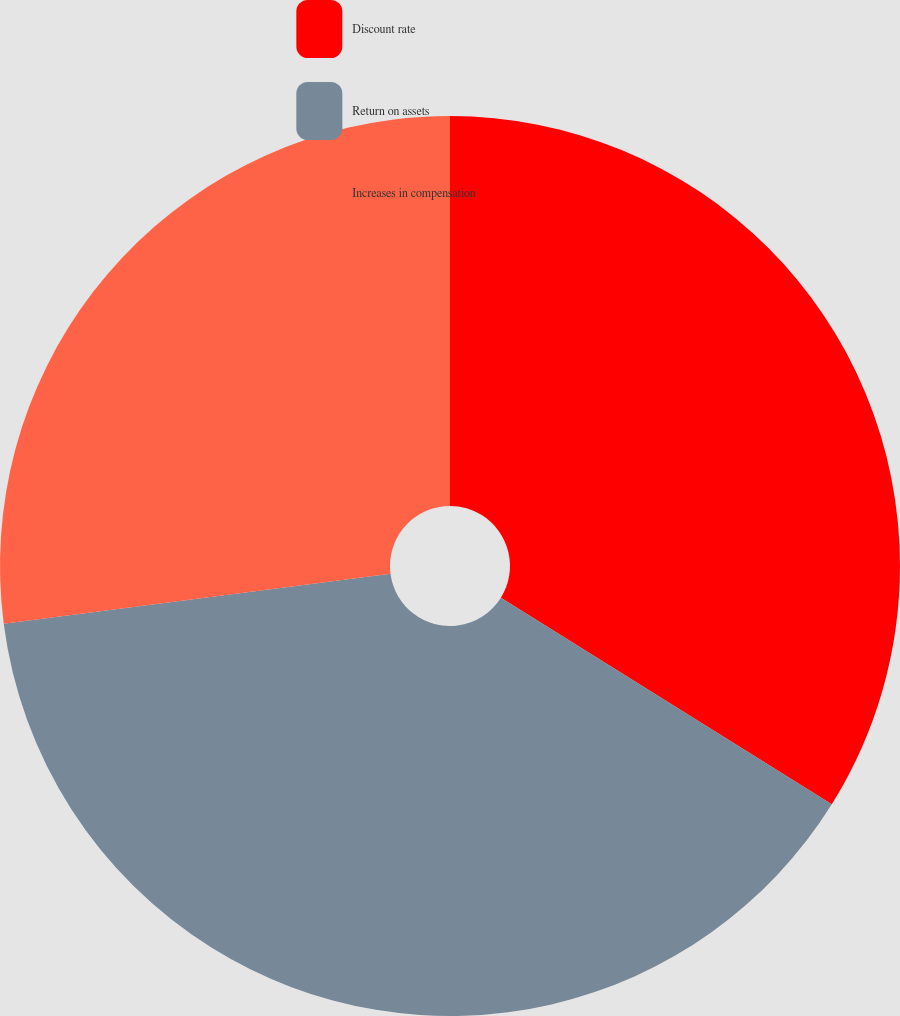Convert chart. <chart><loc_0><loc_0><loc_500><loc_500><pie_chart><fcel>Discount rate<fcel>Return on assets<fcel>Increases in compensation<nl><fcel>33.88%<fcel>39.07%<fcel>27.05%<nl></chart> 